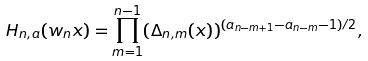<formula> <loc_0><loc_0><loc_500><loc_500>H _ { n , a } ( w _ { n } x ) = \prod _ { m = 1 } ^ { n - 1 } ( \Delta _ { n , m } ( x ) ) ^ { ( a _ { n - m + 1 } - a _ { n - m } - 1 ) / 2 } ,</formula> 